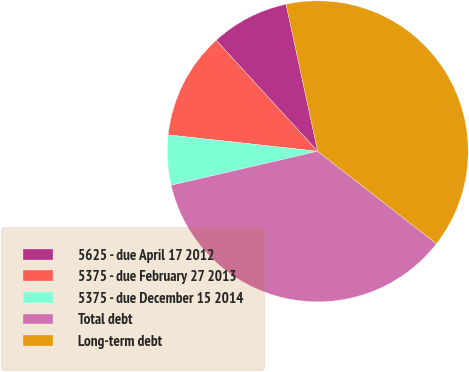Convert chart to OTSL. <chart><loc_0><loc_0><loc_500><loc_500><pie_chart><fcel>5625 - due April 17 2012<fcel>5375 - due February 27 2013<fcel>5375 - due December 15 2014<fcel>Total debt<fcel>Long-term debt<nl><fcel>8.42%<fcel>11.47%<fcel>5.37%<fcel>35.85%<fcel>38.9%<nl></chart> 